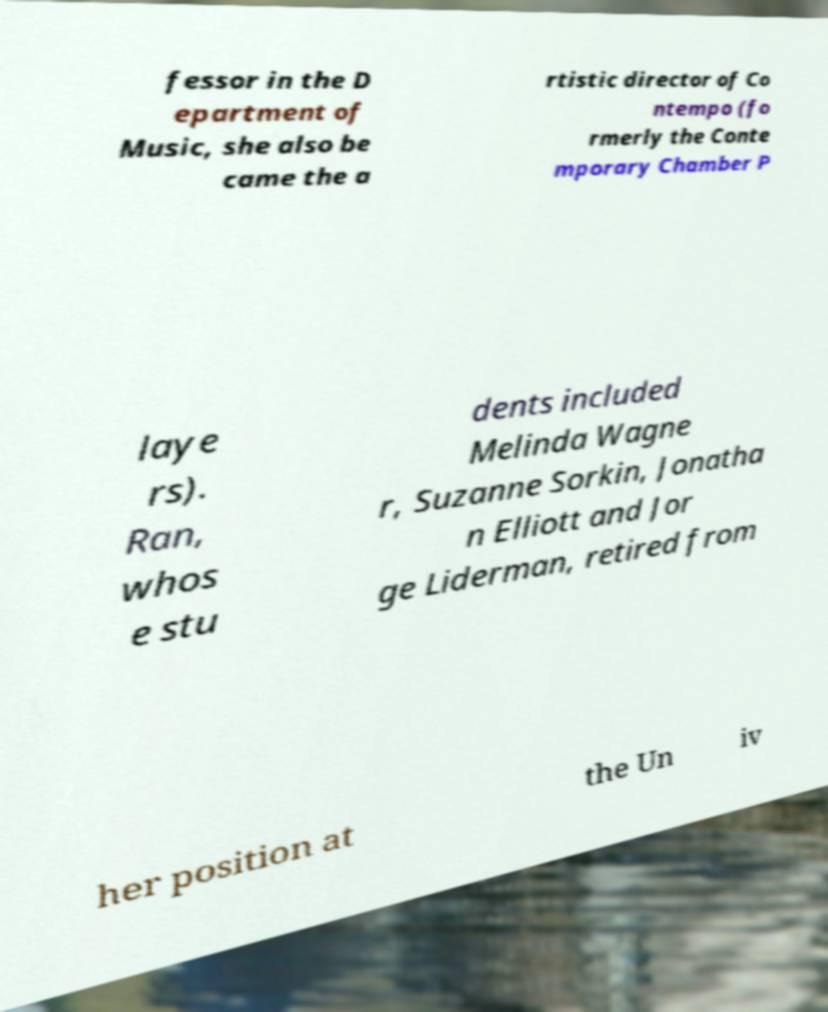There's text embedded in this image that I need extracted. Can you transcribe it verbatim? fessor in the D epartment of Music, she also be came the a rtistic director of Co ntempo (fo rmerly the Conte mporary Chamber P laye rs). Ran, whos e stu dents included Melinda Wagne r, Suzanne Sorkin, Jonatha n Elliott and Jor ge Liderman, retired from her position at the Un iv 